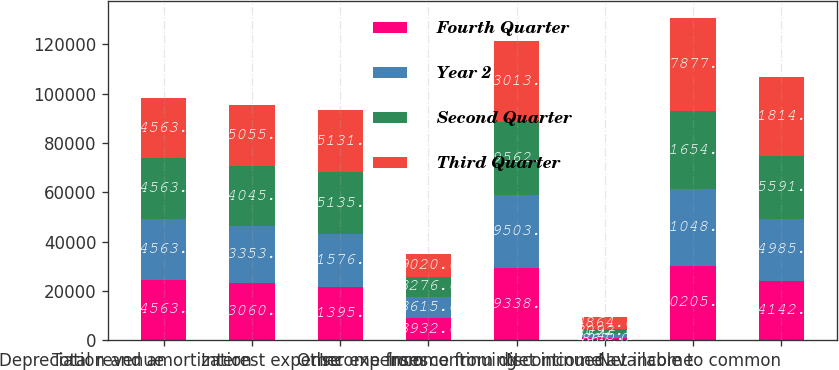Convert chart to OTSL. <chart><loc_0><loc_0><loc_500><loc_500><stacked_bar_chart><ecel><fcel>Total revenue<fcel>Depreciation and amortization<fcel>Interest expense<fcel>Other expenses<fcel>Income from continuing<fcel>Income from discontinued<fcel>Net income<fcel>Net income available to common<nl><fcel>Fourth Quarter<fcel>24563.5<fcel>23060<fcel>21395<fcel>8932<fcel>29338<fcel>867<fcel>30205<fcel>24142<nl><fcel>Year 2<fcel>24563.5<fcel>23353<fcel>21576<fcel>8615<fcel>29503<fcel>1545<fcel>31048<fcel>24985<nl><fcel>Second Quarter<fcel>24563.5<fcel>24045<fcel>25135<fcel>8276<fcel>29562<fcel>2092<fcel>31654<fcel>25591<nl><fcel>Third Quarter<fcel>24563.5<fcel>25055<fcel>25131<fcel>9020<fcel>33013<fcel>4864<fcel>37877<fcel>31814<nl></chart> 